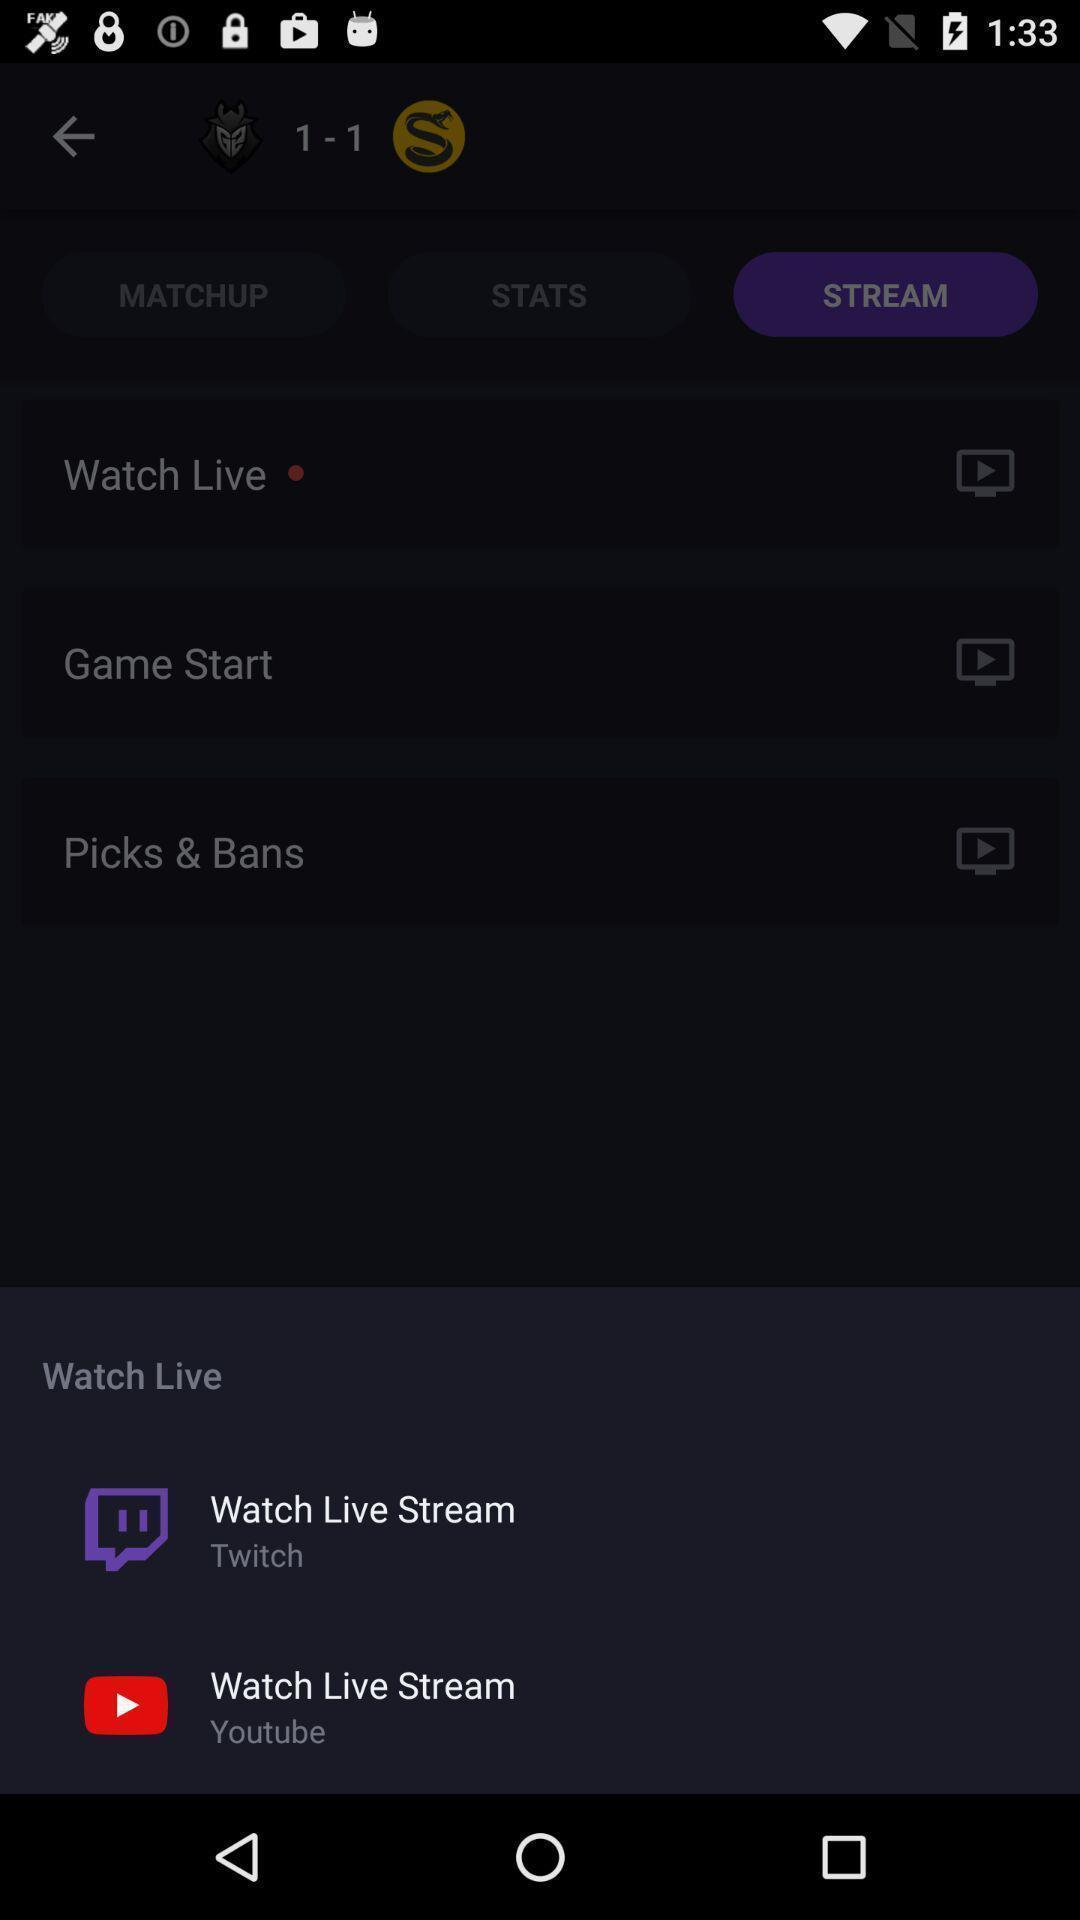Describe the key features of this screenshot. Push up message with live streaming options. 